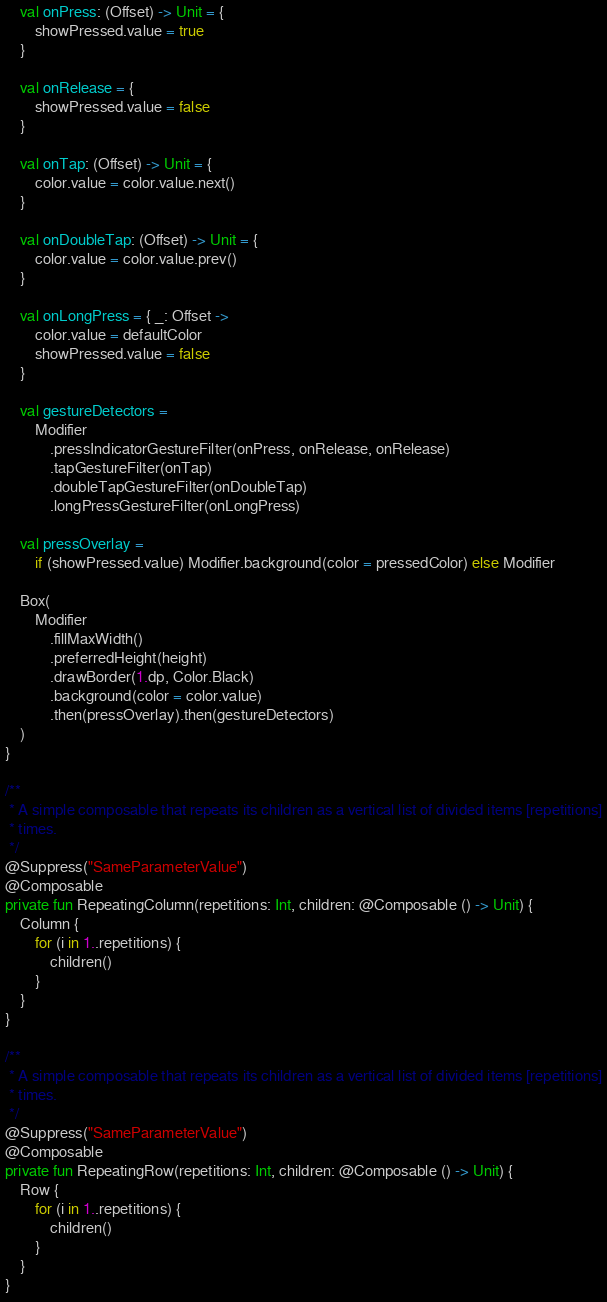<code> <loc_0><loc_0><loc_500><loc_500><_Kotlin_>    val onPress: (Offset) -> Unit = {
        showPressed.value = true
    }

    val onRelease = {
        showPressed.value = false
    }

    val onTap: (Offset) -> Unit = {
        color.value = color.value.next()
    }

    val onDoubleTap: (Offset) -> Unit = {
        color.value = color.value.prev()
    }

    val onLongPress = { _: Offset ->
        color.value = defaultColor
        showPressed.value = false
    }

    val gestureDetectors =
        Modifier
            .pressIndicatorGestureFilter(onPress, onRelease, onRelease)
            .tapGestureFilter(onTap)
            .doubleTapGestureFilter(onDoubleTap)
            .longPressGestureFilter(onLongPress)

    val pressOverlay =
        if (showPressed.value) Modifier.background(color = pressedColor) else Modifier

    Box(
        Modifier
            .fillMaxWidth()
            .preferredHeight(height)
            .drawBorder(1.dp, Color.Black)
            .background(color = color.value)
            .then(pressOverlay).then(gestureDetectors)
    )
}

/**
 * A simple composable that repeats its children as a vertical list of divided items [repetitions]
 * times.
 */
@Suppress("SameParameterValue")
@Composable
private fun RepeatingColumn(repetitions: Int, children: @Composable () -> Unit) {
    Column {
        for (i in 1..repetitions) {
            children()
        }
    }
}

/**
 * A simple composable that repeats its children as a vertical list of divided items [repetitions]
 * times.
 */
@Suppress("SameParameterValue")
@Composable
private fun RepeatingRow(repetitions: Int, children: @Composable () -> Unit) {
    Row {
        for (i in 1..repetitions) {
            children()
        }
    }
}</code> 